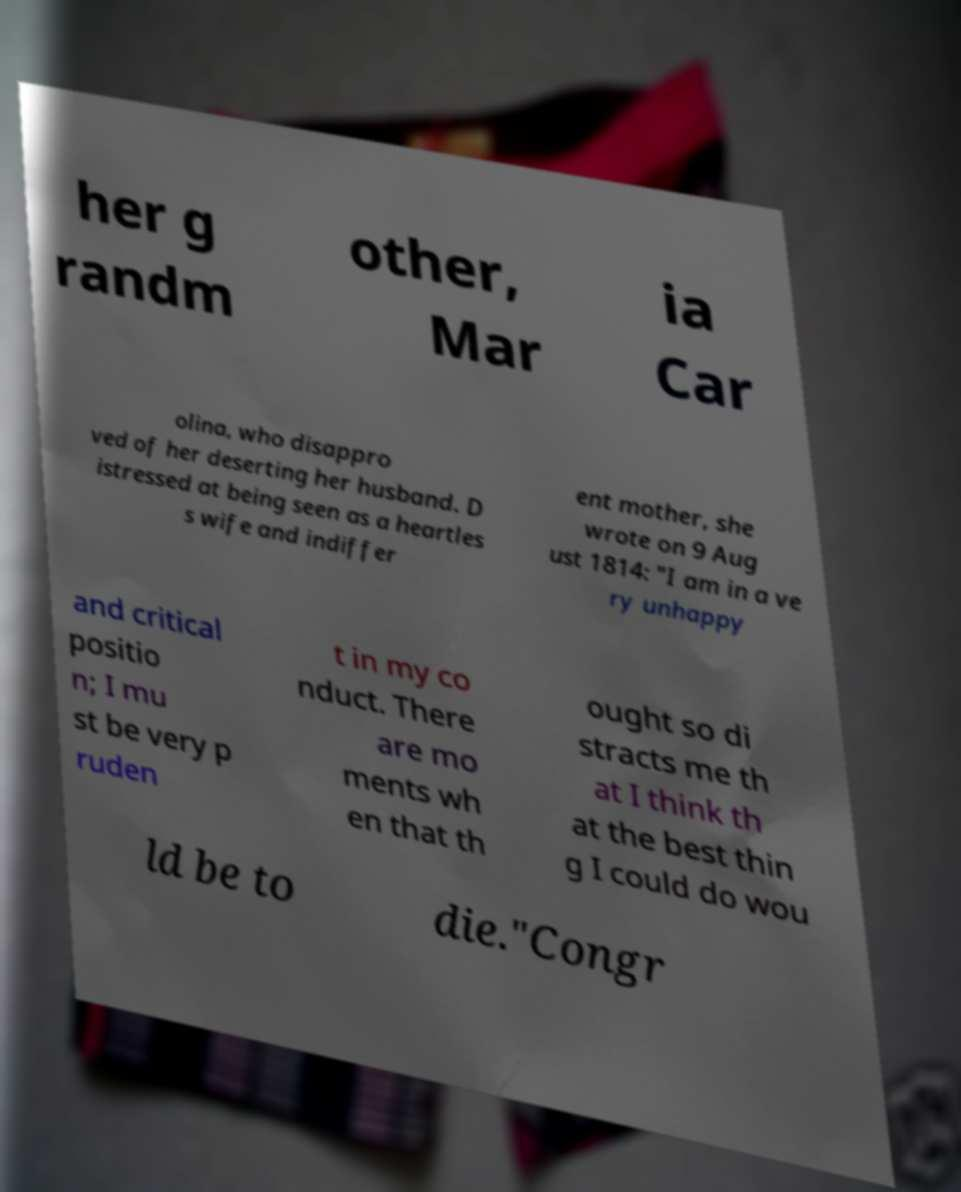There's text embedded in this image that I need extracted. Can you transcribe it verbatim? her g randm other, Mar ia Car olina, who disappro ved of her deserting her husband. D istressed at being seen as a heartles s wife and indiffer ent mother, she wrote on 9 Aug ust 1814: "I am in a ve ry unhappy and critical positio n; I mu st be very p ruden t in my co nduct. There are mo ments wh en that th ought so di stracts me th at I think th at the best thin g I could do wou ld be to die."Congr 